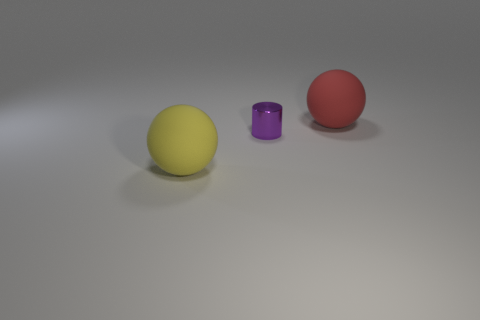Do the big red thing and the purple metallic object that is behind the large yellow thing have the same shape?
Provide a succinct answer. No. How many rubber objects are both to the right of the purple cylinder and to the left of the metal cylinder?
Your answer should be very brief. 0. What is the size of the purple cylinder that is in front of the large sphere behind the tiny purple cylinder?
Offer a very short reply. Small. Are there any shiny objects?
Provide a succinct answer. Yes. What is the material of the thing that is left of the big red thing and on the right side of the yellow object?
Make the answer very short. Metal. Is the number of big rubber spheres right of the tiny cylinder greater than the number of big things that are in front of the yellow rubber ball?
Your response must be concise. Yes. Are there any spheres of the same size as the red rubber object?
Your answer should be compact. Yes. There is a metal object that is right of the matte ball that is on the left side of the rubber sphere that is to the right of the yellow sphere; what is its size?
Offer a terse response. Small. The tiny metallic thing has what color?
Provide a short and direct response. Purple. Are there more large matte spheres that are to the left of the tiny metal thing than green matte balls?
Provide a short and direct response. Yes. 